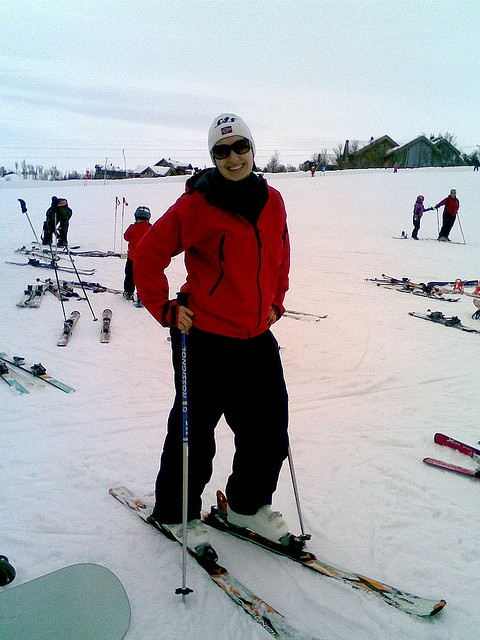Describe the objects in this image and their specific colors. I can see people in white, black, maroon, and gray tones, snowboard in white, teal, and darkgray tones, skis in white, darkgray, black, and gray tones, people in white, black, maroon, and ivory tones, and skis in white, darkgray, teal, black, and lightgray tones in this image. 